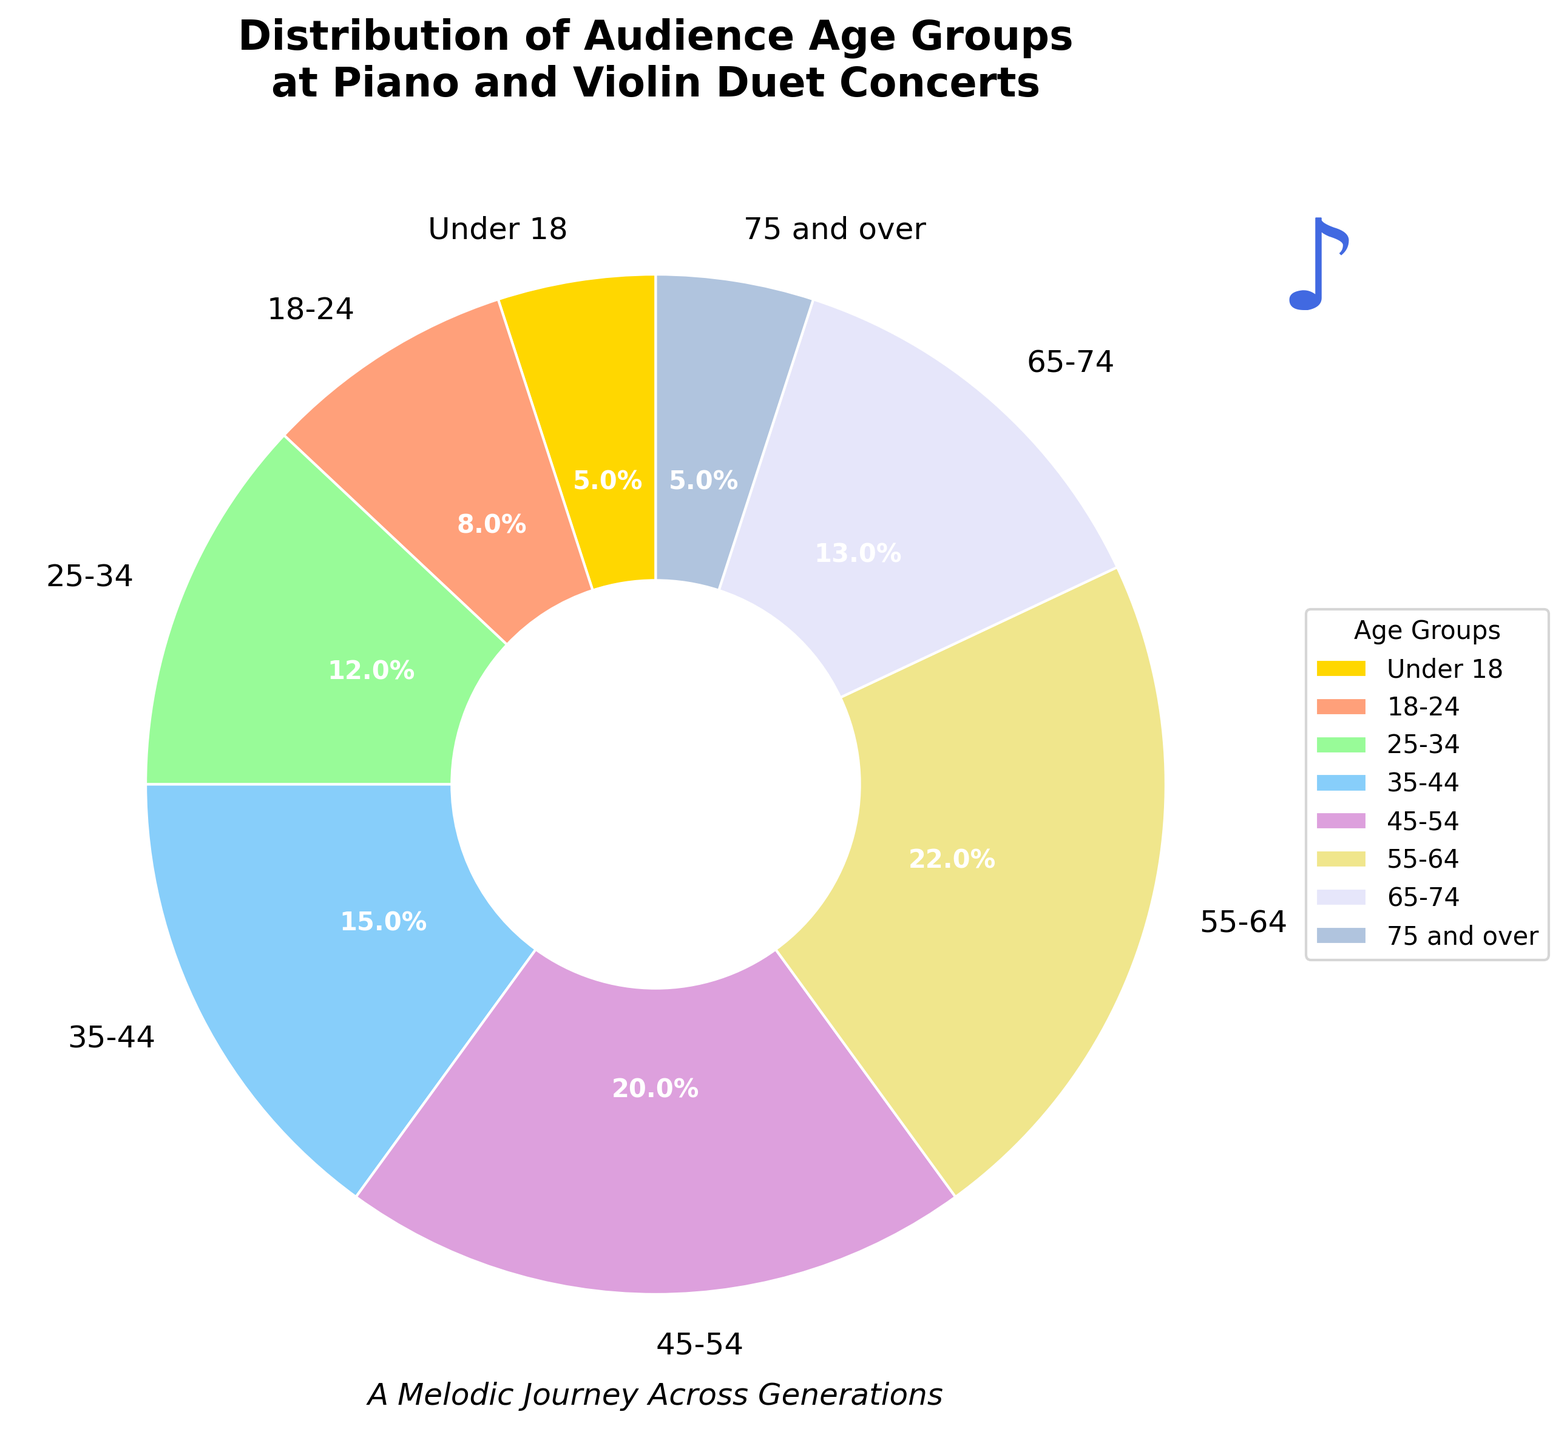What is the most represented age group in the audience? The age group with the highest percentage is the most represented. From the pie chart, the 55-64 age group has the highest percentage at 22%.
Answer: 55-64 What percentage of the audience is aged 25-44? We add the percentages of the 25-34 and 35-44 age groups. From the chart, 25-34 is 12% and 35-44 is 15%. Summing them gives 12% + 15% = 27%.
Answer: 27% How does the percentage of attendees aged 45-54 compare to those aged 18-24? From the chart, the percentage of 45-54 is 20% and for 18-24 it is 8%. The 45-54 group is more than double the 18-24 group.
Answer: 45-54 is more than double 18-24 What is the total percentage of audiences aged 45 and over? We sum the percentages of age groups 45-54, 55-64, 65-74, and 75 and over. From the chart: 20% + 22% + 13% + 5% = 60%.
Answer: 60% Which age groups each constitute 5% of the audience? Examining the chart, the age groups under 18 and 75 and over each have a percentage of 5%.
Answer: Under 18 and 75 and over What is the visual style used to differentiate the age groups? The chart uses different colors to differentiate each age group. Each wedge in the pie chart is a distinct color, making it easy to identify the segments.
Answer: Different colors Which is larger: the percentage of attendees aged 35-54 or those aged under 35? Adding the percentages for 35-44 and 45-54 gives 15% + 20% = 35%. Adding under 18, 18-24, and 25-34 gives 5% + 8% + 12% = 25%. Comparing 35% and 25%, 35-54 is larger.
Answer: 35-54 is larger Does the chart include any decorative elements beyond the data representation? Yes, it includes a musical note and a subtitle "A Melodic Journey Across Generations" as artistic touches.
Answer: Yes What is the second most represented age group? The second highest percentage from the chart is for the 45-54 age group, which is 20%.
Answer: 45-54 